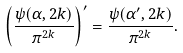Convert formula to latex. <formula><loc_0><loc_0><loc_500><loc_500>\left ( \frac { \psi ( \alpha , 2 k ) } { \pi ^ { 2 k } } \right ) ^ { \prime } = \frac { \psi ( \alpha ^ { \prime } , 2 k ) } { \pi ^ { 2 k } } .</formula> 